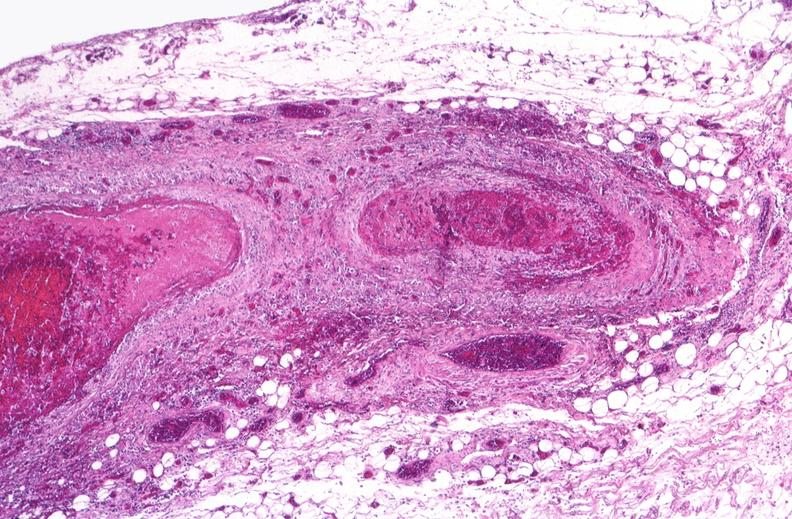s cardiovascular present?
Answer the question using a single word or phrase. Yes 